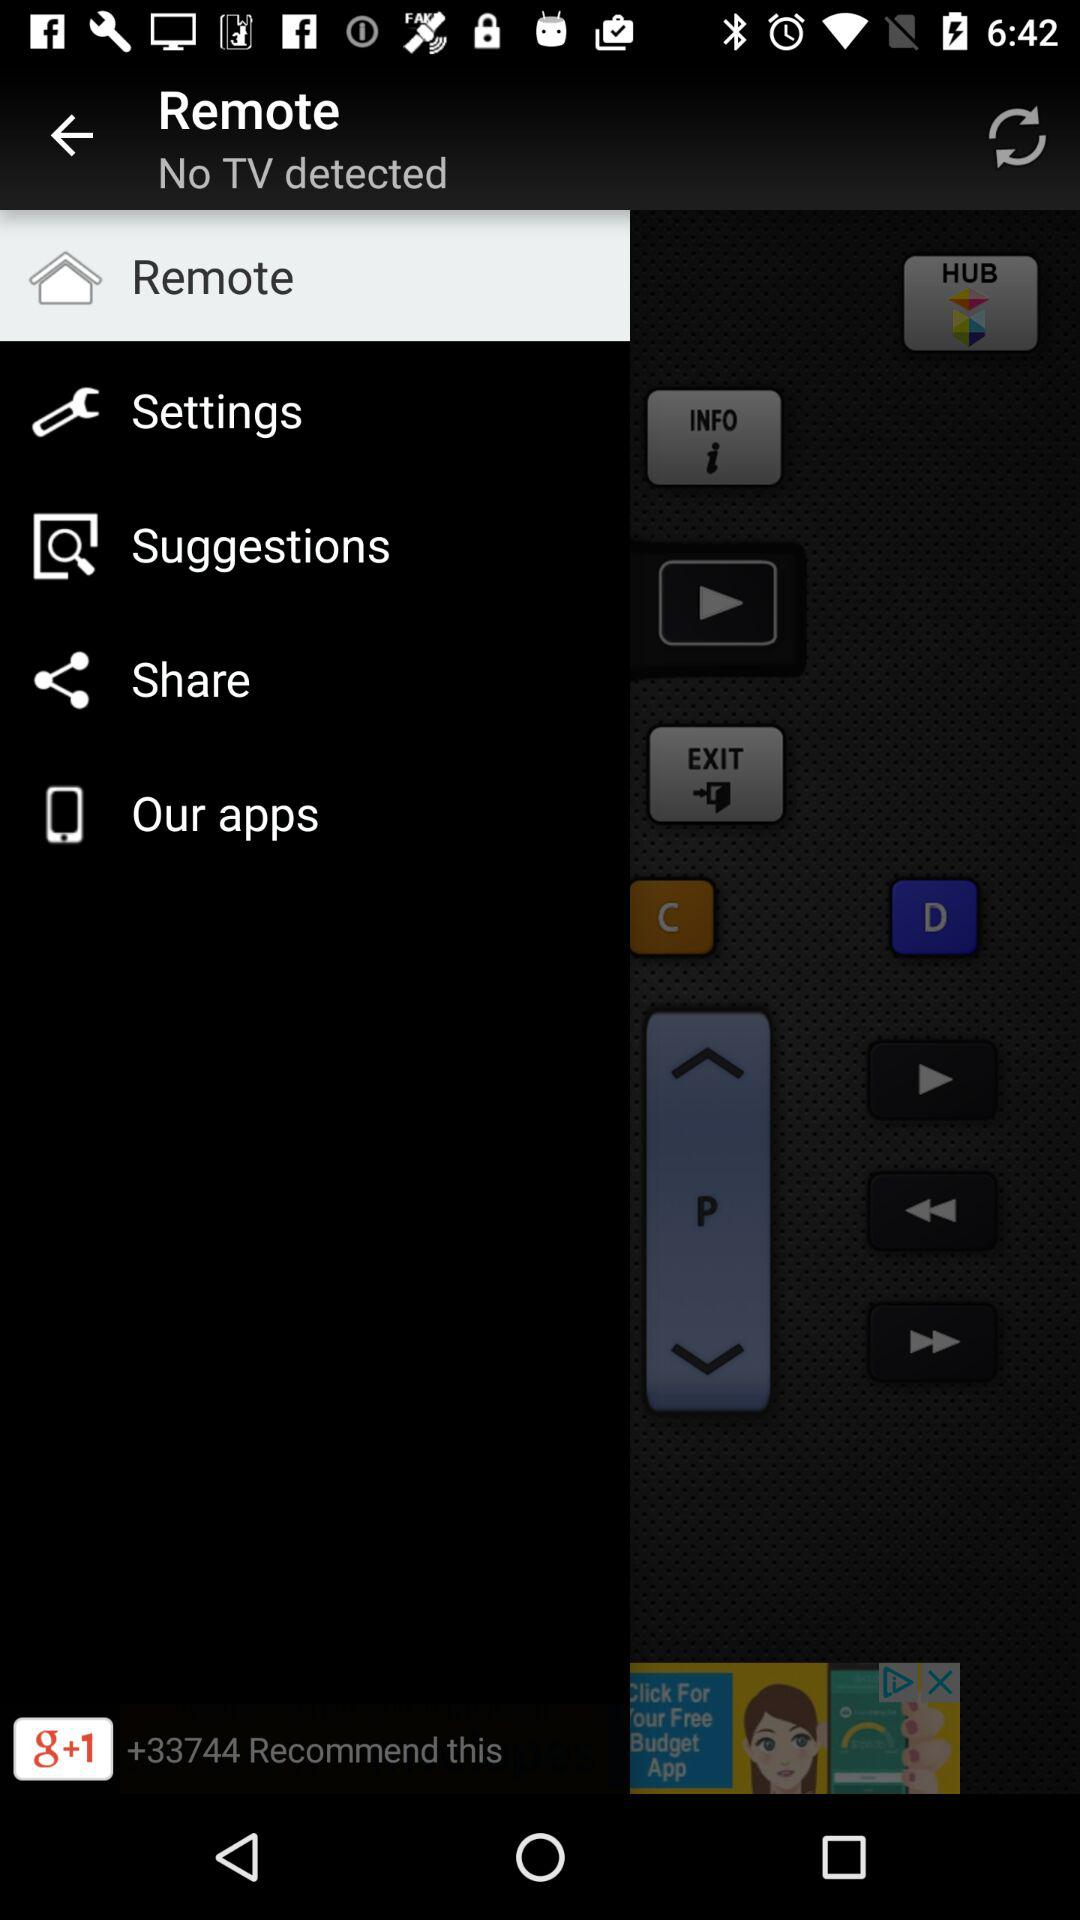How many people recommend "g+1"? There are more than 33744 people who recommend "g+1". 